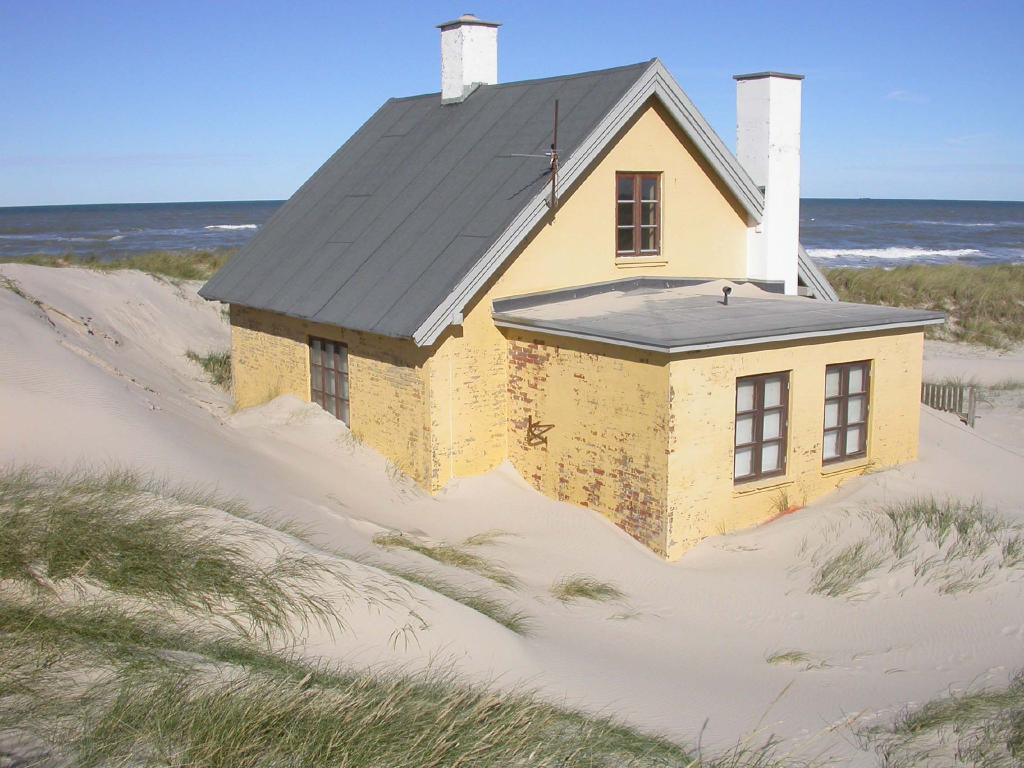Could you give a brief overview of what you see in this image? In the image there is a house and it is surrounded with a lot of sand and green grass. Behind the house there is a sea. 